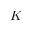<formula> <loc_0><loc_0><loc_500><loc_500>K</formula> 